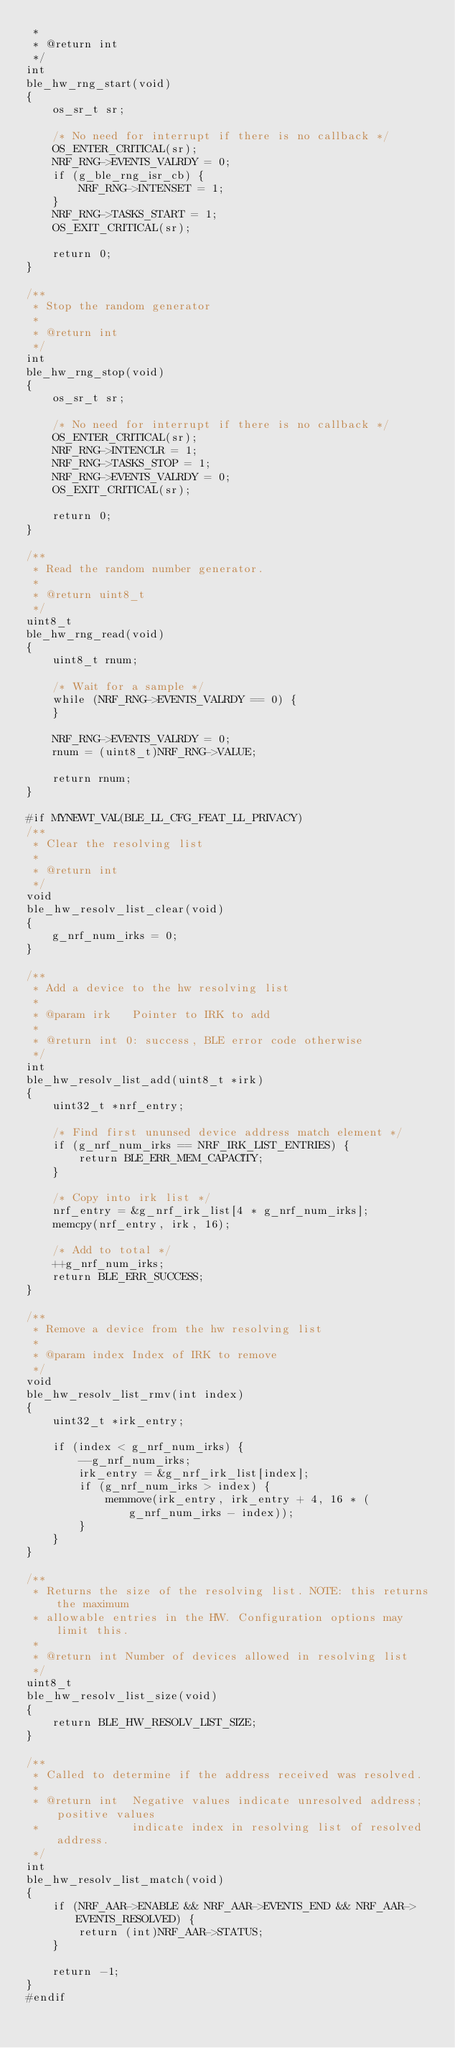Convert code to text. <code><loc_0><loc_0><loc_500><loc_500><_C_> *
 * @return int
 */
int
ble_hw_rng_start(void)
{
    os_sr_t sr;

    /* No need for interrupt if there is no callback */
    OS_ENTER_CRITICAL(sr);
    NRF_RNG->EVENTS_VALRDY = 0;
    if (g_ble_rng_isr_cb) {
        NRF_RNG->INTENSET = 1;
    }
    NRF_RNG->TASKS_START = 1;
    OS_EXIT_CRITICAL(sr);

    return 0;
}

/**
 * Stop the random generator
 *
 * @return int
 */
int
ble_hw_rng_stop(void)
{
    os_sr_t sr;

    /* No need for interrupt if there is no callback */
    OS_ENTER_CRITICAL(sr);
    NRF_RNG->INTENCLR = 1;
    NRF_RNG->TASKS_STOP = 1;
    NRF_RNG->EVENTS_VALRDY = 0;
    OS_EXIT_CRITICAL(sr);

    return 0;
}

/**
 * Read the random number generator.
 *
 * @return uint8_t
 */
uint8_t
ble_hw_rng_read(void)
{
    uint8_t rnum;

    /* Wait for a sample */
    while (NRF_RNG->EVENTS_VALRDY == 0) {
    }

    NRF_RNG->EVENTS_VALRDY = 0;
    rnum = (uint8_t)NRF_RNG->VALUE;

    return rnum;
}

#if MYNEWT_VAL(BLE_LL_CFG_FEAT_LL_PRIVACY)
/**
 * Clear the resolving list
 *
 * @return int
 */
void
ble_hw_resolv_list_clear(void)
{
    g_nrf_num_irks = 0;
}

/**
 * Add a device to the hw resolving list
 *
 * @param irk   Pointer to IRK to add
 *
 * @return int 0: success, BLE error code otherwise
 */
int
ble_hw_resolv_list_add(uint8_t *irk)
{
    uint32_t *nrf_entry;

    /* Find first ununsed device address match element */
    if (g_nrf_num_irks == NRF_IRK_LIST_ENTRIES) {
        return BLE_ERR_MEM_CAPACITY;
    }

    /* Copy into irk list */
    nrf_entry = &g_nrf_irk_list[4 * g_nrf_num_irks];
    memcpy(nrf_entry, irk, 16);

    /* Add to total */
    ++g_nrf_num_irks;
    return BLE_ERR_SUCCESS;
}

/**
 * Remove a device from the hw resolving list
 *
 * @param index Index of IRK to remove
 */
void
ble_hw_resolv_list_rmv(int index)
{
    uint32_t *irk_entry;

    if (index < g_nrf_num_irks) {
        --g_nrf_num_irks;
        irk_entry = &g_nrf_irk_list[index];
        if (g_nrf_num_irks > index) {
            memmove(irk_entry, irk_entry + 4, 16 * (g_nrf_num_irks - index));
        }
    }
}

/**
 * Returns the size of the resolving list. NOTE: this returns the maximum
 * allowable entries in the HW. Configuration options may limit this.
 *
 * @return int Number of devices allowed in resolving list
 */
uint8_t
ble_hw_resolv_list_size(void)
{
    return BLE_HW_RESOLV_LIST_SIZE;
}

/**
 * Called to determine if the address received was resolved.
 *
 * @return int  Negative values indicate unresolved address; positive values
 *              indicate index in resolving list of resolved address.
 */
int
ble_hw_resolv_list_match(void)
{
    if (NRF_AAR->ENABLE && NRF_AAR->EVENTS_END && NRF_AAR->EVENTS_RESOLVED) {
        return (int)NRF_AAR->STATUS;
    }

    return -1;
}
#endif
</code> 